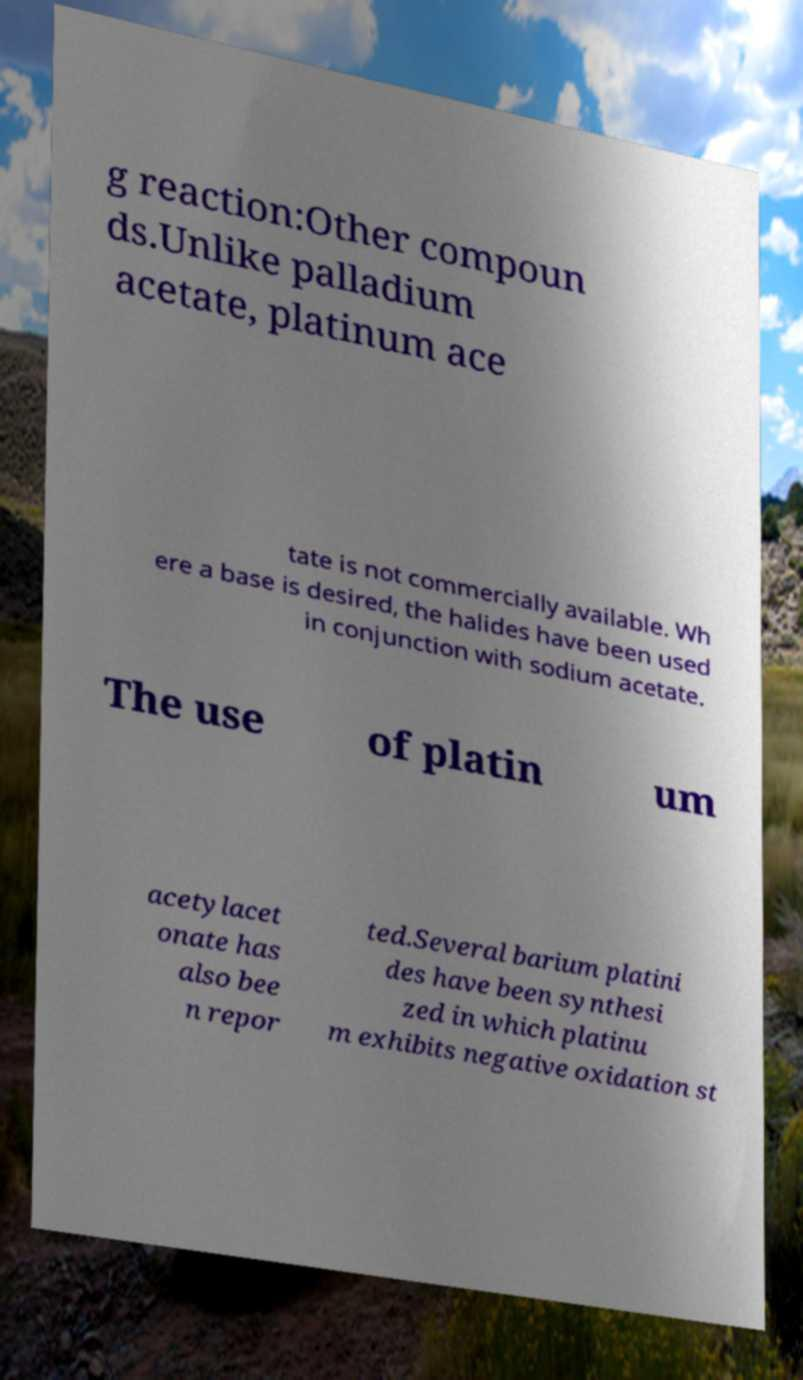Please read and relay the text visible in this image. What does it say? g reaction:Other compoun ds.Unlike palladium acetate, platinum ace tate is not commercially available. Wh ere a base is desired, the halides have been used in conjunction with sodium acetate. The use of platin um acetylacet onate has also bee n repor ted.Several barium platini des have been synthesi zed in which platinu m exhibits negative oxidation st 